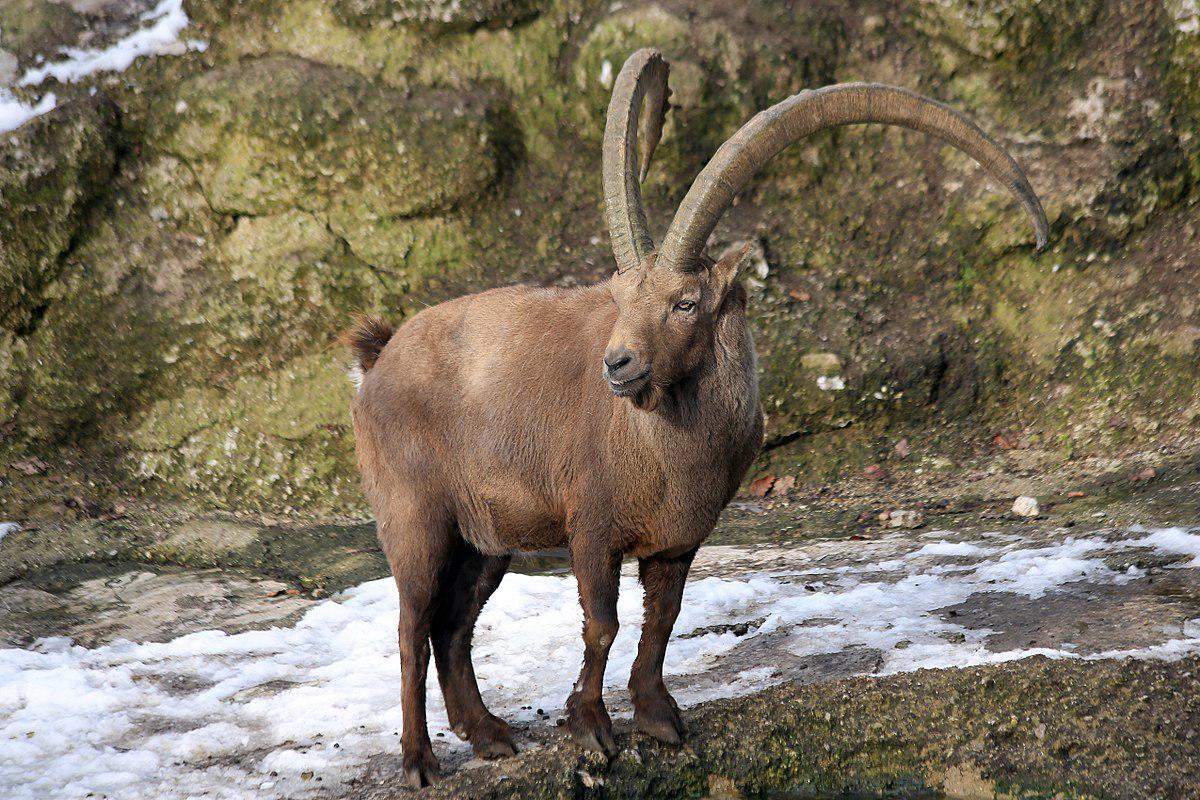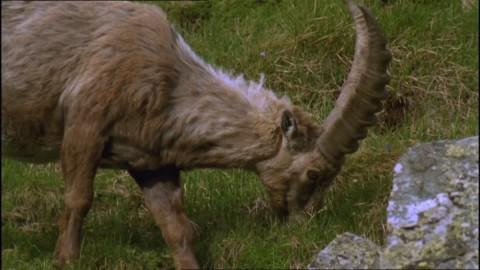The first image is the image on the left, the second image is the image on the right. For the images shown, is this caption "a single Ibex is eating grass" true? Answer yes or no. Yes. The first image is the image on the left, the second image is the image on the right. Evaluate the accuracy of this statement regarding the images: "Each ram on the left has it's nose down sniffing an object.". Is it true? Answer yes or no. No. 